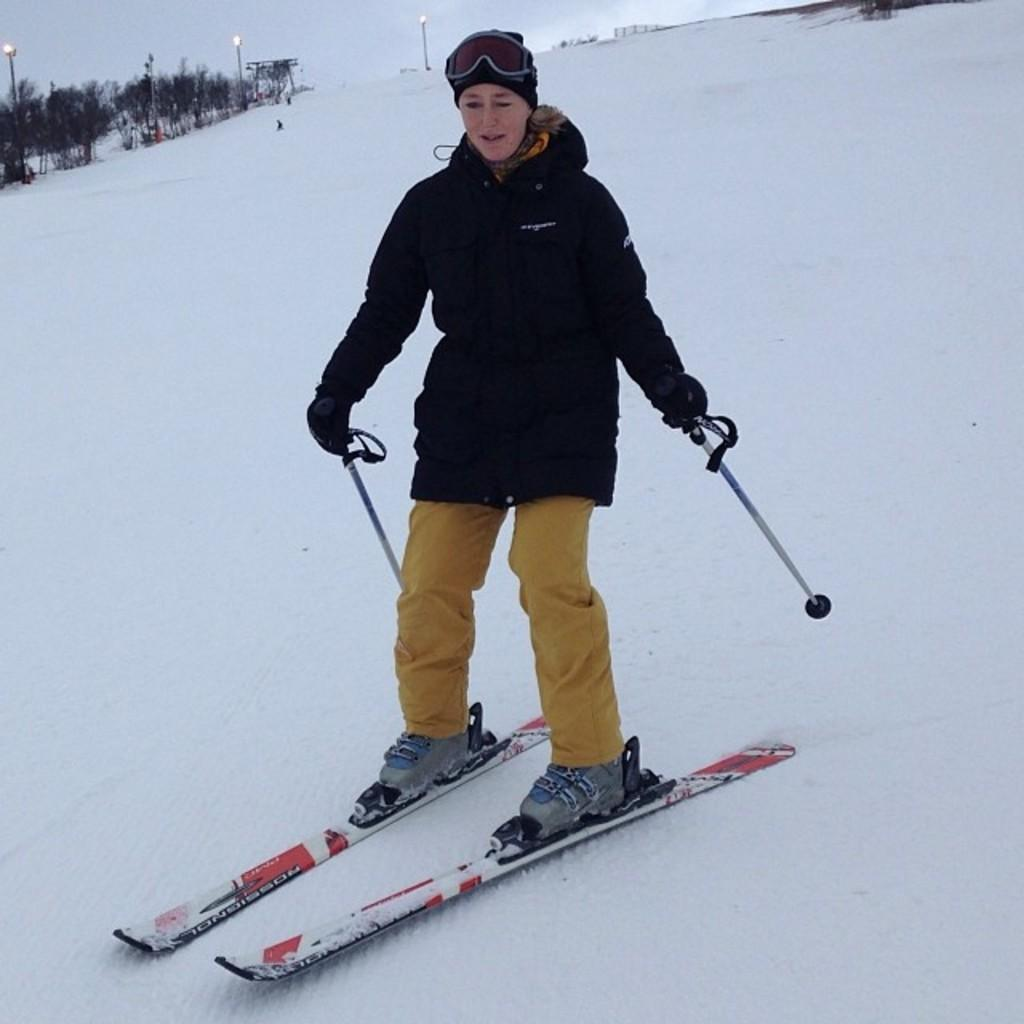Who is the main subject in the image? There is a lady in the center of the image. What is the lady doing in the image? The lady is ice skating. What is the weather like in the image? There is snow in the area surrounding the image, suggesting a cold and wintry setting. What can be seen in the top left side of the image? There are trees in the top left side of the image. What type of juice is being served at the end of the ice skating rink in the image? There is no juice or ice skating rink present in the image; it features a lady ice skating in a snowy area with trees in the background. 